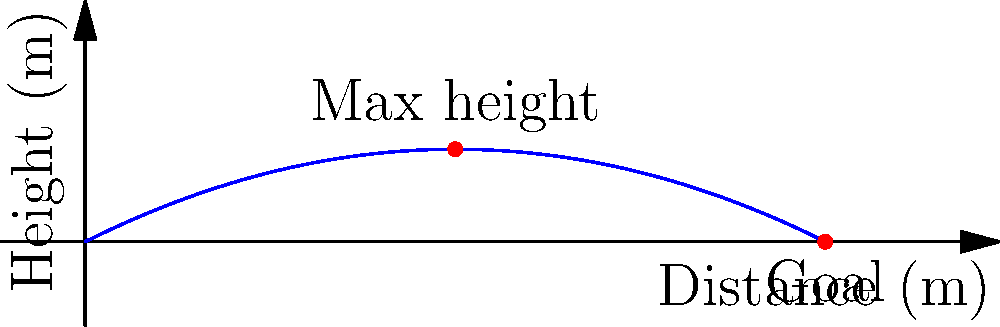As a former football coach, analyze the graph representing the trajectory of a curved free kick. If the ball reaches its maximum height at 25 meters from the kicker, what is the approximate distance to the goal? To solve this problem, let's follow these steps:

1. Understand the graph: The x-axis represents the distance from the kicker, and the y-axis represents the height of the ball.

2. Identify key points: 
   - The maximum height is reached at x = 25 meters.
   - The ball reaches the ground (y = 0) at the end of its trajectory.

3. Analyze the symmetry: In an ideal parabolic trajectory, the distance from the maximum height to the end point is approximately equal to the distance from the starting point to the maximum height.

4. Calculate the distance:
   - Distance to max height = 25 meters
   - Approximate remaining distance = 25 meters
   - Total distance ≈ 25 + 25 = 50 meters

5. Verify on the graph: The curve indeed touches the x-axis at around 50 meters.

Therefore, based on the symmetry of the parabolic trajectory and the information provided in the graph, the approximate distance to the goal is 50 meters.
Answer: 50 meters 